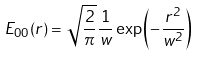<formula> <loc_0><loc_0><loc_500><loc_500>E _ { 0 0 } ( r ) = \sqrt { \frac { 2 } { \pi } } \frac { 1 } { w } \exp \left ( - \frac { r ^ { 2 } } { w ^ { 2 } } \right )</formula> 